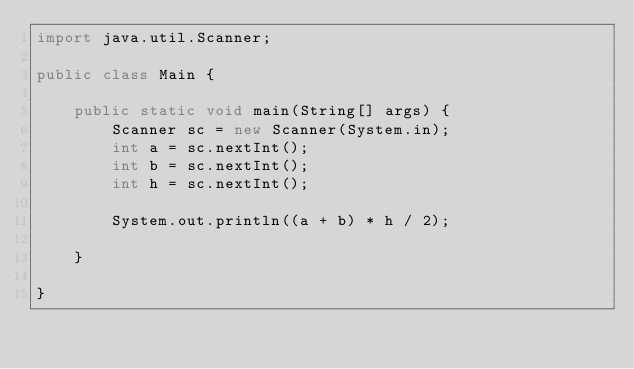Convert code to text. <code><loc_0><loc_0><loc_500><loc_500><_Java_>import java.util.Scanner;

public class Main {

	public static void main(String[] args) {
		Scanner sc = new Scanner(System.in);
		int a = sc.nextInt();
		int b = sc.nextInt();
		int h = sc.nextInt();
		
		System.out.println((a + b) * h / 2);

	}

}
</code> 